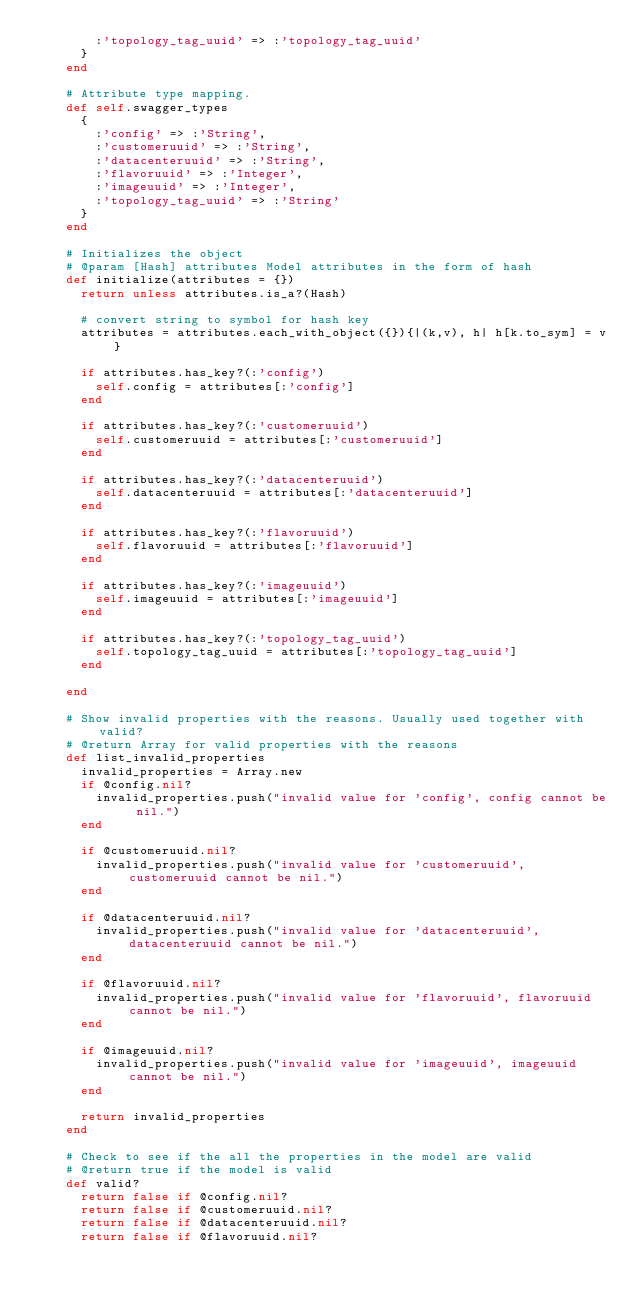Convert code to text. <code><loc_0><loc_0><loc_500><loc_500><_Ruby_>        :'topology_tag_uuid' => :'topology_tag_uuid'
      }
    end

    # Attribute type mapping.
    def self.swagger_types
      {
        :'config' => :'String',
        :'customeruuid' => :'String',
        :'datacenteruuid' => :'String',
        :'flavoruuid' => :'Integer',
        :'imageuuid' => :'Integer',
        :'topology_tag_uuid' => :'String'
      }
    end

    # Initializes the object
    # @param [Hash] attributes Model attributes in the form of hash
    def initialize(attributes = {})
      return unless attributes.is_a?(Hash)

      # convert string to symbol for hash key
      attributes = attributes.each_with_object({}){|(k,v), h| h[k.to_sym] = v}

      if attributes.has_key?(:'config')
        self.config = attributes[:'config']
      end

      if attributes.has_key?(:'customeruuid')
        self.customeruuid = attributes[:'customeruuid']
      end

      if attributes.has_key?(:'datacenteruuid')
        self.datacenteruuid = attributes[:'datacenteruuid']
      end

      if attributes.has_key?(:'flavoruuid')
        self.flavoruuid = attributes[:'flavoruuid']
      end

      if attributes.has_key?(:'imageuuid')
        self.imageuuid = attributes[:'imageuuid']
      end

      if attributes.has_key?(:'topology_tag_uuid')
        self.topology_tag_uuid = attributes[:'topology_tag_uuid']
      end

    end

    # Show invalid properties with the reasons. Usually used together with valid?
    # @return Array for valid properties with the reasons
    def list_invalid_properties
      invalid_properties = Array.new
      if @config.nil?
        invalid_properties.push("invalid value for 'config', config cannot be nil.")
      end

      if @customeruuid.nil?
        invalid_properties.push("invalid value for 'customeruuid', customeruuid cannot be nil.")
      end

      if @datacenteruuid.nil?
        invalid_properties.push("invalid value for 'datacenteruuid', datacenteruuid cannot be nil.")
      end

      if @flavoruuid.nil?
        invalid_properties.push("invalid value for 'flavoruuid', flavoruuid cannot be nil.")
      end

      if @imageuuid.nil?
        invalid_properties.push("invalid value for 'imageuuid', imageuuid cannot be nil.")
      end

      return invalid_properties
    end

    # Check to see if the all the properties in the model are valid
    # @return true if the model is valid
    def valid?
      return false if @config.nil?
      return false if @customeruuid.nil?
      return false if @datacenteruuid.nil?
      return false if @flavoruuid.nil?</code> 